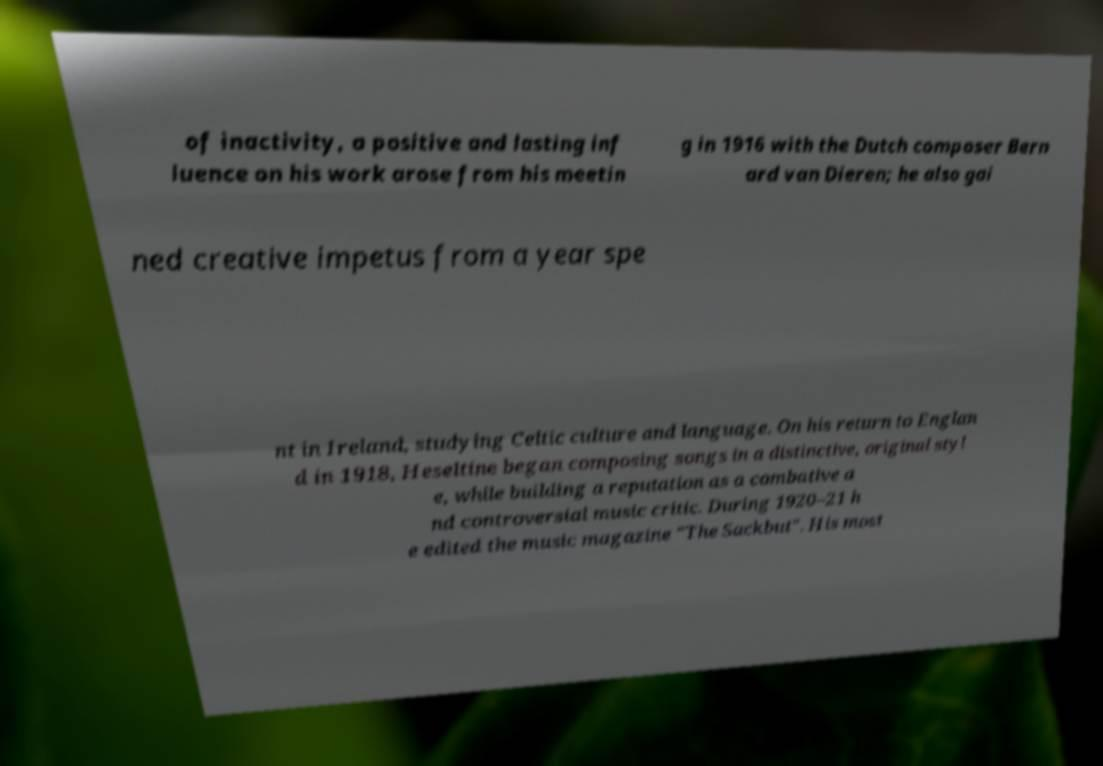Could you assist in decoding the text presented in this image and type it out clearly? of inactivity, a positive and lasting inf luence on his work arose from his meetin g in 1916 with the Dutch composer Bern ard van Dieren; he also gai ned creative impetus from a year spe nt in Ireland, studying Celtic culture and language. On his return to Englan d in 1918, Heseltine began composing songs in a distinctive, original styl e, while building a reputation as a combative a nd controversial music critic. During 1920–21 h e edited the music magazine "The Sackbut". His most 